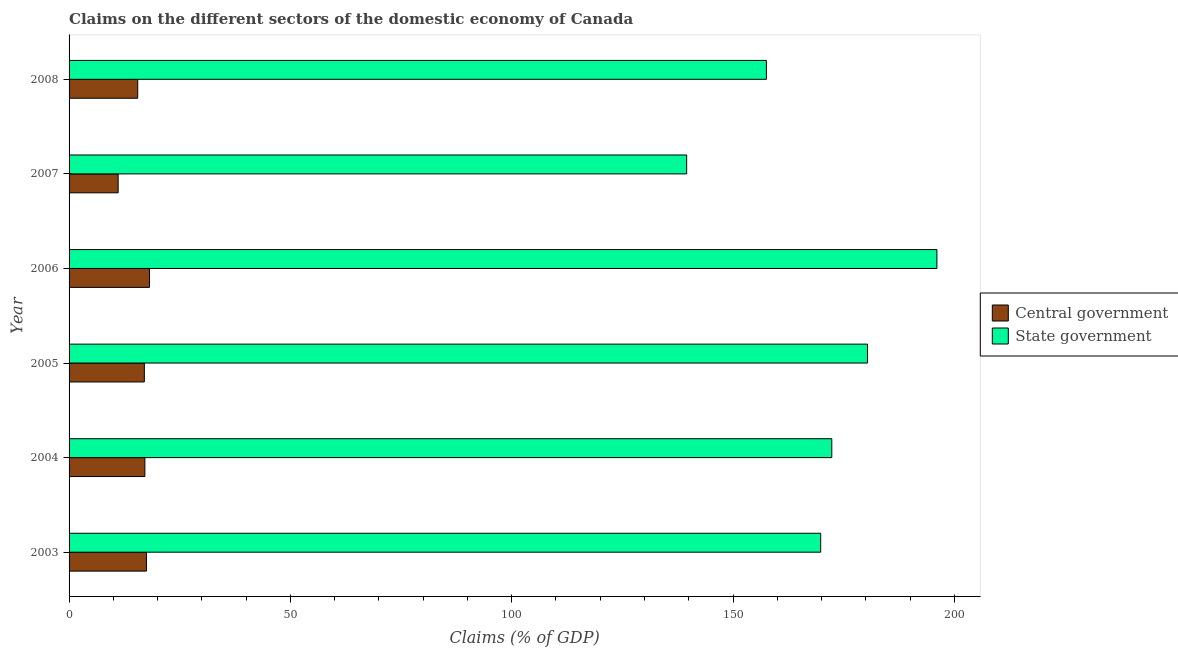How many different coloured bars are there?
Ensure brevity in your answer.  2. How many groups of bars are there?
Provide a short and direct response. 6. How many bars are there on the 4th tick from the top?
Ensure brevity in your answer.  2. How many bars are there on the 5th tick from the bottom?
Offer a terse response. 2. What is the claims on central government in 2007?
Your answer should be compact. 11.09. Across all years, what is the maximum claims on state government?
Provide a succinct answer. 196.06. Across all years, what is the minimum claims on state government?
Ensure brevity in your answer.  139.53. In which year was the claims on central government maximum?
Offer a terse response. 2006. What is the total claims on central government in the graph?
Your response must be concise. 96.37. What is the difference between the claims on central government in 2004 and that in 2008?
Make the answer very short. 1.61. What is the difference between the claims on state government in 2008 and the claims on central government in 2006?
Ensure brevity in your answer.  139.38. What is the average claims on state government per year?
Keep it short and to the point. 169.27. In the year 2007, what is the difference between the claims on central government and claims on state government?
Provide a succinct answer. -128.44. What is the ratio of the claims on central government in 2003 to that in 2005?
Offer a very short reply. 1.03. What is the difference between the highest and the second highest claims on central government?
Make the answer very short. 0.69. What is the difference between the highest and the lowest claims on central government?
Keep it short and to the point. 7.08. Is the sum of the claims on state government in 2004 and 2006 greater than the maximum claims on central government across all years?
Ensure brevity in your answer.  Yes. What does the 2nd bar from the top in 2005 represents?
Provide a succinct answer. Central government. What does the 1st bar from the bottom in 2006 represents?
Make the answer very short. Central government. How many bars are there?
Provide a succinct answer. 12. How many years are there in the graph?
Provide a succinct answer. 6. What is the difference between two consecutive major ticks on the X-axis?
Keep it short and to the point. 50. Are the values on the major ticks of X-axis written in scientific E-notation?
Offer a very short reply. No. How many legend labels are there?
Give a very brief answer. 2. What is the title of the graph?
Provide a succinct answer. Claims on the different sectors of the domestic economy of Canada. Does "Study and work" appear as one of the legend labels in the graph?
Keep it short and to the point. No. What is the label or title of the X-axis?
Ensure brevity in your answer.  Claims (% of GDP). What is the Claims (% of GDP) in Central government in 2003?
Your answer should be very brief. 17.48. What is the Claims (% of GDP) in State government in 2003?
Provide a short and direct response. 169.81. What is the Claims (% of GDP) of Central government in 2004?
Ensure brevity in your answer.  17.13. What is the Claims (% of GDP) in State government in 2004?
Your answer should be very brief. 172.31. What is the Claims (% of GDP) in Central government in 2005?
Provide a succinct answer. 17. What is the Claims (% of GDP) of State government in 2005?
Ensure brevity in your answer.  180.39. What is the Claims (% of GDP) in Central government in 2006?
Make the answer very short. 18.17. What is the Claims (% of GDP) in State government in 2006?
Keep it short and to the point. 196.06. What is the Claims (% of GDP) of Central government in 2007?
Offer a very short reply. 11.09. What is the Claims (% of GDP) of State government in 2007?
Your response must be concise. 139.53. What is the Claims (% of GDP) of Central government in 2008?
Offer a very short reply. 15.51. What is the Claims (% of GDP) of State government in 2008?
Provide a succinct answer. 157.54. Across all years, what is the maximum Claims (% of GDP) of Central government?
Provide a short and direct response. 18.17. Across all years, what is the maximum Claims (% of GDP) in State government?
Keep it short and to the point. 196.06. Across all years, what is the minimum Claims (% of GDP) of Central government?
Provide a succinct answer. 11.09. Across all years, what is the minimum Claims (% of GDP) in State government?
Keep it short and to the point. 139.53. What is the total Claims (% of GDP) of Central government in the graph?
Your response must be concise. 96.37. What is the total Claims (% of GDP) in State government in the graph?
Your answer should be very brief. 1015.64. What is the difference between the Claims (% of GDP) in Central government in 2003 and that in 2004?
Your response must be concise. 0.36. What is the difference between the Claims (% of GDP) in State government in 2003 and that in 2004?
Offer a very short reply. -2.51. What is the difference between the Claims (% of GDP) in Central government in 2003 and that in 2005?
Make the answer very short. 0.48. What is the difference between the Claims (% of GDP) of State government in 2003 and that in 2005?
Make the answer very short. -10.59. What is the difference between the Claims (% of GDP) of Central government in 2003 and that in 2006?
Give a very brief answer. -0.68. What is the difference between the Claims (% of GDP) in State government in 2003 and that in 2006?
Ensure brevity in your answer.  -26.25. What is the difference between the Claims (% of GDP) in Central government in 2003 and that in 2007?
Make the answer very short. 6.39. What is the difference between the Claims (% of GDP) of State government in 2003 and that in 2007?
Provide a succinct answer. 30.28. What is the difference between the Claims (% of GDP) of Central government in 2003 and that in 2008?
Give a very brief answer. 1.97. What is the difference between the Claims (% of GDP) in State government in 2003 and that in 2008?
Offer a very short reply. 12.26. What is the difference between the Claims (% of GDP) of Central government in 2004 and that in 2005?
Keep it short and to the point. 0.12. What is the difference between the Claims (% of GDP) in State government in 2004 and that in 2005?
Provide a short and direct response. -8.08. What is the difference between the Claims (% of GDP) of Central government in 2004 and that in 2006?
Provide a succinct answer. -1.04. What is the difference between the Claims (% of GDP) in State government in 2004 and that in 2006?
Provide a short and direct response. -23.75. What is the difference between the Claims (% of GDP) in Central government in 2004 and that in 2007?
Provide a short and direct response. 6.04. What is the difference between the Claims (% of GDP) in State government in 2004 and that in 2007?
Offer a very short reply. 32.78. What is the difference between the Claims (% of GDP) in Central government in 2004 and that in 2008?
Your answer should be very brief. 1.61. What is the difference between the Claims (% of GDP) in State government in 2004 and that in 2008?
Keep it short and to the point. 14.77. What is the difference between the Claims (% of GDP) in Central government in 2005 and that in 2006?
Provide a short and direct response. -1.16. What is the difference between the Claims (% of GDP) in State government in 2005 and that in 2006?
Keep it short and to the point. -15.67. What is the difference between the Claims (% of GDP) of Central government in 2005 and that in 2007?
Keep it short and to the point. 5.92. What is the difference between the Claims (% of GDP) in State government in 2005 and that in 2007?
Offer a very short reply. 40.87. What is the difference between the Claims (% of GDP) in Central government in 2005 and that in 2008?
Make the answer very short. 1.49. What is the difference between the Claims (% of GDP) of State government in 2005 and that in 2008?
Your answer should be very brief. 22.85. What is the difference between the Claims (% of GDP) in Central government in 2006 and that in 2007?
Offer a very short reply. 7.08. What is the difference between the Claims (% of GDP) of State government in 2006 and that in 2007?
Ensure brevity in your answer.  56.53. What is the difference between the Claims (% of GDP) of Central government in 2006 and that in 2008?
Offer a terse response. 2.65. What is the difference between the Claims (% of GDP) of State government in 2006 and that in 2008?
Provide a short and direct response. 38.52. What is the difference between the Claims (% of GDP) in Central government in 2007 and that in 2008?
Offer a very short reply. -4.42. What is the difference between the Claims (% of GDP) of State government in 2007 and that in 2008?
Your answer should be compact. -18.02. What is the difference between the Claims (% of GDP) in Central government in 2003 and the Claims (% of GDP) in State government in 2004?
Offer a terse response. -154.83. What is the difference between the Claims (% of GDP) of Central government in 2003 and the Claims (% of GDP) of State government in 2005?
Your answer should be compact. -162.91. What is the difference between the Claims (% of GDP) of Central government in 2003 and the Claims (% of GDP) of State government in 2006?
Your response must be concise. -178.58. What is the difference between the Claims (% of GDP) of Central government in 2003 and the Claims (% of GDP) of State government in 2007?
Offer a terse response. -122.05. What is the difference between the Claims (% of GDP) of Central government in 2003 and the Claims (% of GDP) of State government in 2008?
Keep it short and to the point. -140.06. What is the difference between the Claims (% of GDP) in Central government in 2004 and the Claims (% of GDP) in State government in 2005?
Your answer should be compact. -163.27. What is the difference between the Claims (% of GDP) of Central government in 2004 and the Claims (% of GDP) of State government in 2006?
Make the answer very short. -178.94. What is the difference between the Claims (% of GDP) in Central government in 2004 and the Claims (% of GDP) in State government in 2007?
Keep it short and to the point. -122.4. What is the difference between the Claims (% of GDP) in Central government in 2004 and the Claims (% of GDP) in State government in 2008?
Your answer should be very brief. -140.42. What is the difference between the Claims (% of GDP) of Central government in 2005 and the Claims (% of GDP) of State government in 2006?
Make the answer very short. -179.06. What is the difference between the Claims (% of GDP) of Central government in 2005 and the Claims (% of GDP) of State government in 2007?
Your response must be concise. -122.52. What is the difference between the Claims (% of GDP) in Central government in 2005 and the Claims (% of GDP) in State government in 2008?
Offer a terse response. -140.54. What is the difference between the Claims (% of GDP) in Central government in 2006 and the Claims (% of GDP) in State government in 2007?
Offer a very short reply. -121.36. What is the difference between the Claims (% of GDP) of Central government in 2006 and the Claims (% of GDP) of State government in 2008?
Your answer should be very brief. -139.38. What is the difference between the Claims (% of GDP) of Central government in 2007 and the Claims (% of GDP) of State government in 2008?
Keep it short and to the point. -146.46. What is the average Claims (% of GDP) of Central government per year?
Give a very brief answer. 16.06. What is the average Claims (% of GDP) in State government per year?
Ensure brevity in your answer.  169.27. In the year 2003, what is the difference between the Claims (% of GDP) of Central government and Claims (% of GDP) of State government?
Offer a terse response. -152.33. In the year 2004, what is the difference between the Claims (% of GDP) in Central government and Claims (% of GDP) in State government?
Make the answer very short. -155.19. In the year 2005, what is the difference between the Claims (% of GDP) of Central government and Claims (% of GDP) of State government?
Keep it short and to the point. -163.39. In the year 2006, what is the difference between the Claims (% of GDP) in Central government and Claims (% of GDP) in State government?
Provide a short and direct response. -177.9. In the year 2007, what is the difference between the Claims (% of GDP) in Central government and Claims (% of GDP) in State government?
Ensure brevity in your answer.  -128.44. In the year 2008, what is the difference between the Claims (% of GDP) in Central government and Claims (% of GDP) in State government?
Make the answer very short. -142.03. What is the ratio of the Claims (% of GDP) of Central government in 2003 to that in 2004?
Offer a terse response. 1.02. What is the ratio of the Claims (% of GDP) of State government in 2003 to that in 2004?
Your response must be concise. 0.99. What is the ratio of the Claims (% of GDP) in Central government in 2003 to that in 2005?
Your answer should be compact. 1.03. What is the ratio of the Claims (% of GDP) of State government in 2003 to that in 2005?
Your answer should be very brief. 0.94. What is the ratio of the Claims (% of GDP) of Central government in 2003 to that in 2006?
Provide a succinct answer. 0.96. What is the ratio of the Claims (% of GDP) of State government in 2003 to that in 2006?
Your answer should be compact. 0.87. What is the ratio of the Claims (% of GDP) in Central government in 2003 to that in 2007?
Keep it short and to the point. 1.58. What is the ratio of the Claims (% of GDP) in State government in 2003 to that in 2007?
Provide a short and direct response. 1.22. What is the ratio of the Claims (% of GDP) of Central government in 2003 to that in 2008?
Ensure brevity in your answer.  1.13. What is the ratio of the Claims (% of GDP) of State government in 2003 to that in 2008?
Make the answer very short. 1.08. What is the ratio of the Claims (% of GDP) of Central government in 2004 to that in 2005?
Provide a short and direct response. 1.01. What is the ratio of the Claims (% of GDP) in State government in 2004 to that in 2005?
Your answer should be compact. 0.96. What is the ratio of the Claims (% of GDP) of Central government in 2004 to that in 2006?
Offer a terse response. 0.94. What is the ratio of the Claims (% of GDP) of State government in 2004 to that in 2006?
Make the answer very short. 0.88. What is the ratio of the Claims (% of GDP) in Central government in 2004 to that in 2007?
Provide a succinct answer. 1.54. What is the ratio of the Claims (% of GDP) of State government in 2004 to that in 2007?
Your answer should be very brief. 1.24. What is the ratio of the Claims (% of GDP) of Central government in 2004 to that in 2008?
Give a very brief answer. 1.1. What is the ratio of the Claims (% of GDP) of State government in 2004 to that in 2008?
Offer a very short reply. 1.09. What is the ratio of the Claims (% of GDP) in Central government in 2005 to that in 2006?
Give a very brief answer. 0.94. What is the ratio of the Claims (% of GDP) in State government in 2005 to that in 2006?
Provide a short and direct response. 0.92. What is the ratio of the Claims (% of GDP) in Central government in 2005 to that in 2007?
Your response must be concise. 1.53. What is the ratio of the Claims (% of GDP) in State government in 2005 to that in 2007?
Provide a succinct answer. 1.29. What is the ratio of the Claims (% of GDP) of Central government in 2005 to that in 2008?
Your answer should be compact. 1.1. What is the ratio of the Claims (% of GDP) of State government in 2005 to that in 2008?
Make the answer very short. 1.15. What is the ratio of the Claims (% of GDP) of Central government in 2006 to that in 2007?
Ensure brevity in your answer.  1.64. What is the ratio of the Claims (% of GDP) of State government in 2006 to that in 2007?
Offer a terse response. 1.41. What is the ratio of the Claims (% of GDP) in Central government in 2006 to that in 2008?
Ensure brevity in your answer.  1.17. What is the ratio of the Claims (% of GDP) in State government in 2006 to that in 2008?
Ensure brevity in your answer.  1.24. What is the ratio of the Claims (% of GDP) in Central government in 2007 to that in 2008?
Offer a terse response. 0.71. What is the ratio of the Claims (% of GDP) in State government in 2007 to that in 2008?
Make the answer very short. 0.89. What is the difference between the highest and the second highest Claims (% of GDP) in Central government?
Provide a succinct answer. 0.68. What is the difference between the highest and the second highest Claims (% of GDP) in State government?
Provide a short and direct response. 15.67. What is the difference between the highest and the lowest Claims (% of GDP) in Central government?
Your answer should be compact. 7.08. What is the difference between the highest and the lowest Claims (% of GDP) in State government?
Provide a short and direct response. 56.53. 